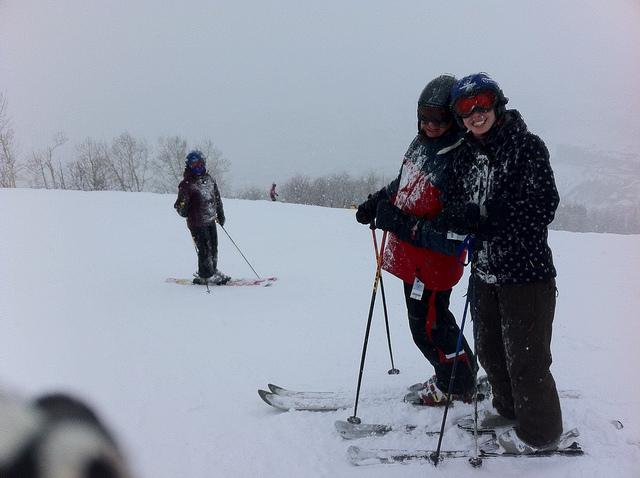To which elevation will the persons pictured here likely go to on their skis?

Choices:
A) sea level
B) higher
C) same
D) lower lower 